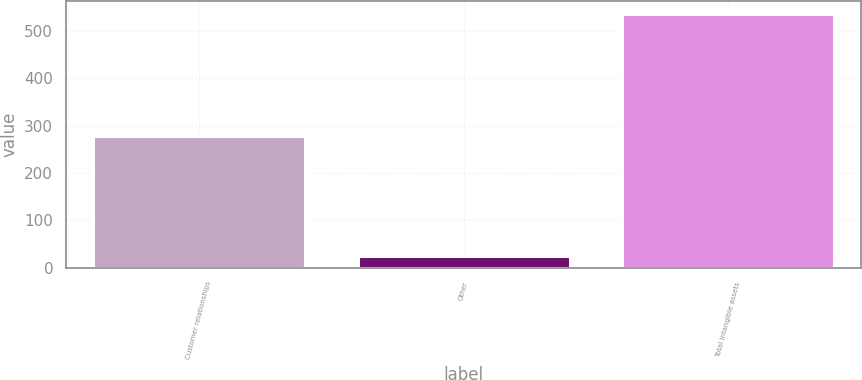<chart> <loc_0><loc_0><loc_500><loc_500><bar_chart><fcel>Customer relationships<fcel>Other<fcel>Total intangible assets<nl><fcel>278.6<fcel>24.4<fcel>536.2<nl></chart> 